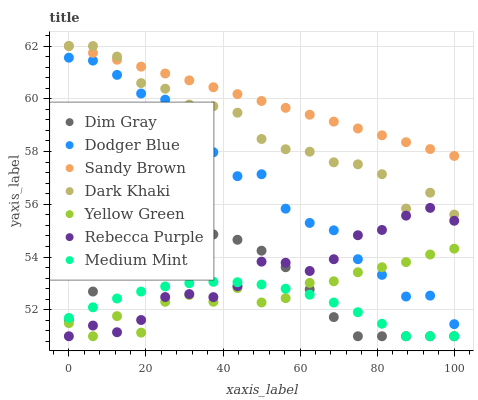Does Medium Mint have the minimum area under the curve?
Answer yes or no. Yes. Does Sandy Brown have the maximum area under the curve?
Answer yes or no. Yes. Does Dim Gray have the minimum area under the curve?
Answer yes or no. No. Does Dim Gray have the maximum area under the curve?
Answer yes or no. No. Is Sandy Brown the smoothest?
Answer yes or no. Yes. Is Yellow Green the roughest?
Answer yes or no. Yes. Is Dim Gray the smoothest?
Answer yes or no. No. Is Dim Gray the roughest?
Answer yes or no. No. Does Medium Mint have the lowest value?
Answer yes or no. Yes. Does Dark Khaki have the lowest value?
Answer yes or no. No. Does Sandy Brown have the highest value?
Answer yes or no. Yes. Does Dim Gray have the highest value?
Answer yes or no. No. Is Dim Gray less than Sandy Brown?
Answer yes or no. Yes. Is Dark Khaki greater than Medium Mint?
Answer yes or no. Yes. Does Dim Gray intersect Yellow Green?
Answer yes or no. Yes. Is Dim Gray less than Yellow Green?
Answer yes or no. No. Is Dim Gray greater than Yellow Green?
Answer yes or no. No. Does Dim Gray intersect Sandy Brown?
Answer yes or no. No. 